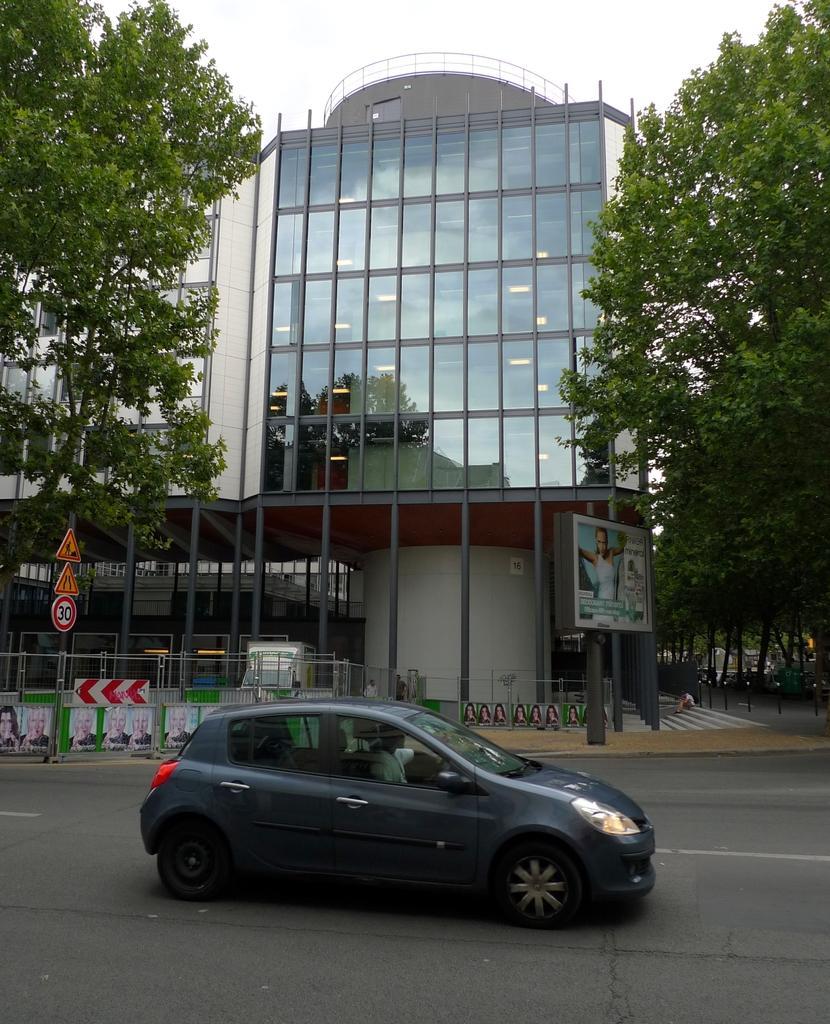Please provide a concise description of this image. In this image we can see a vehicle which is moving on road and at the background of the image there is building and some trees. 